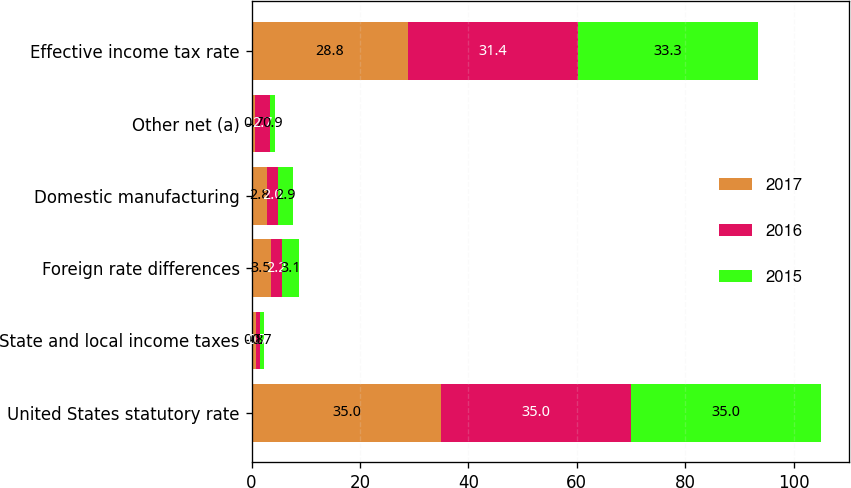Convert chart to OTSL. <chart><loc_0><loc_0><loc_500><loc_500><stacked_bar_chart><ecel><fcel>United States statutory rate<fcel>State and local income taxes<fcel>Foreign rate differences<fcel>Domestic manufacturing<fcel>Other net (a)<fcel>Effective income tax rate<nl><fcel>2017<fcel>35<fcel>0.8<fcel>3.5<fcel>2.8<fcel>0.7<fcel>28.8<nl><fcel>2016<fcel>35<fcel>0.7<fcel>2.2<fcel>2<fcel>2.7<fcel>31.4<nl><fcel>2015<fcel>35<fcel>0.7<fcel>3.1<fcel>2.9<fcel>0.9<fcel>33.3<nl></chart> 